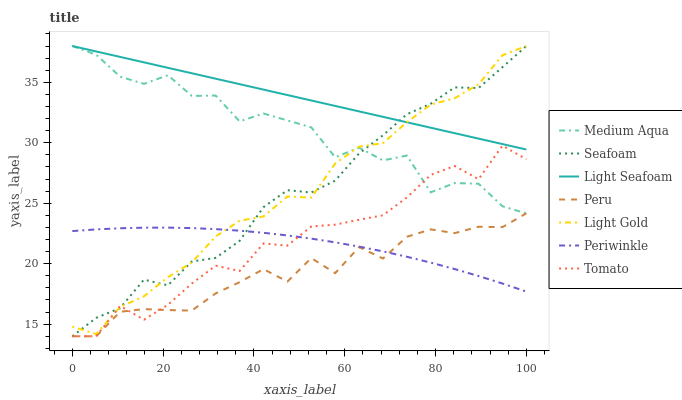Does Peru have the minimum area under the curve?
Answer yes or no. Yes. Does Light Seafoam have the maximum area under the curve?
Answer yes or no. Yes. Does Seafoam have the minimum area under the curve?
Answer yes or no. No. Does Seafoam have the maximum area under the curve?
Answer yes or no. No. Is Light Seafoam the smoothest?
Answer yes or no. Yes. Is Medium Aqua the roughest?
Answer yes or no. Yes. Is Seafoam the smoothest?
Answer yes or no. No. Is Seafoam the roughest?
Answer yes or no. No. Does Tomato have the lowest value?
Answer yes or no. Yes. Does Periwinkle have the lowest value?
Answer yes or no. No. Does Light Gold have the highest value?
Answer yes or no. Yes. Does Periwinkle have the highest value?
Answer yes or no. No. Is Peru less than Light Seafoam?
Answer yes or no. Yes. Is Medium Aqua greater than Periwinkle?
Answer yes or no. Yes. Does Seafoam intersect Light Gold?
Answer yes or no. Yes. Is Seafoam less than Light Gold?
Answer yes or no. No. Is Seafoam greater than Light Gold?
Answer yes or no. No. Does Peru intersect Light Seafoam?
Answer yes or no. No. 